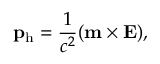<formula> <loc_0><loc_0><loc_500><loc_500>\mathbf p _ { h } = \frac { 1 } { c ^ { 2 } } ( \mathbf m \times \mathbf E ) ,</formula> 